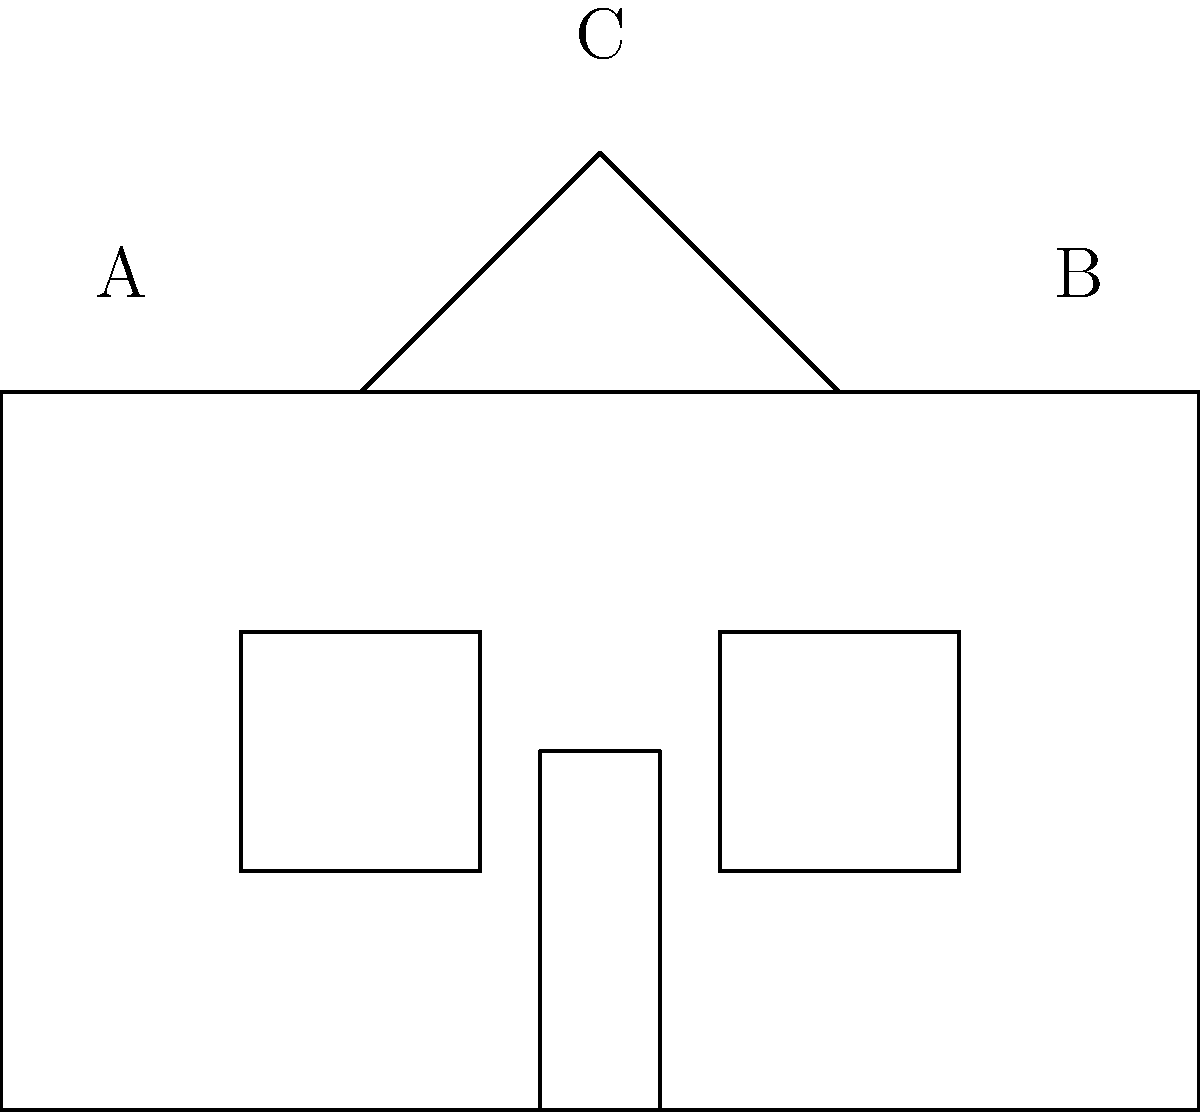The sketch above represents a simplified version of a historic building in Lufkin. Which architectural style does this building most likely represent, and what key features support this classification? To determine the architectural style of this building, let's analyze its key features step-by-step:

1. Overall shape: The building has a simple, rectangular base structure, which is common in many traditional architectural styles.

2. Roof: The roof is steeply pitched and triangular, forming a distinct A-frame shape. This is a characteristic feature of the Gothic Revival style, which was popular in the United States from the 1830s to 1890s.

3. Symmetry: The building appears to be symmetrical, with evenly spaced windows on either side of the central door. This symmetry is common in many classical and revival styles, including Gothic Revival.

4. Windows: The windows are tall and narrow, another typical feature of Gothic Revival architecture. In actual Gothic Revival buildings, these windows would often be pointed arch windows, though our simplified sketch doesn't show this detail.

5. Central door: The presence of a central door further emphasizes the building's symmetry and is consistent with Gothic Revival design.

6. Lack of ornamentation: While our sketch is simplified, it doesn't show elaborate decorations. Gothic Revival buildings could range from simple to ornate, so this doesn't rule out the style.

Given these features, particularly the steeply pitched roof and the overall symmetry, this building most closely represents the Gothic Revival style. This style was often used for churches, schools, and public buildings in the 19th century, making it a plausible choice for a historic building in Lufkin, Texas.

It's worth noting that Lufkin, founded in the late 19th century, would have seen various architectural styles. While Gothic Revival was more common earlier in the 19th century, its influence persisted, especially in smaller towns and for certain types of buildings.
Answer: Gothic Revival 